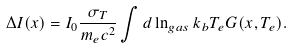<formula> <loc_0><loc_0><loc_500><loc_500>\Delta I ( x ) = I _ { 0 } \frac { \sigma _ { T } } { m _ { e } c ^ { 2 } } \int d \ln _ { g a s } k _ { b } T _ { e } G ( x , T _ { e } ) .</formula> 